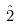Convert formula to latex. <formula><loc_0><loc_0><loc_500><loc_500>\hat { 2 }</formula> 